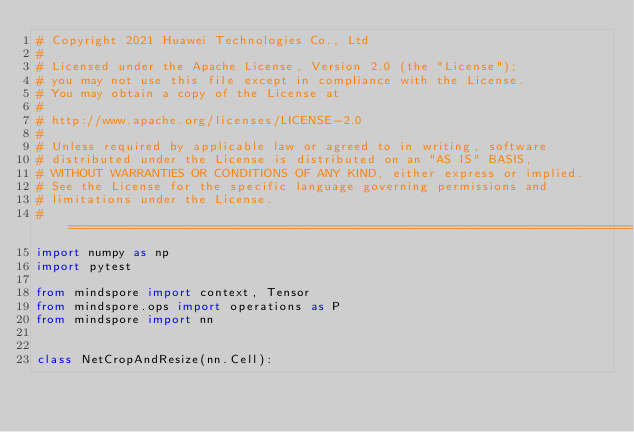<code> <loc_0><loc_0><loc_500><loc_500><_Python_># Copyright 2021 Huawei Technologies Co., Ltd
#
# Licensed under the Apache License, Version 2.0 (the "License");
# you may not use this file except in compliance with the License.
# You may obtain a copy of the License at
#
# http://www.apache.org/licenses/LICENSE-2.0
#
# Unless required by applicable law or agreed to in writing, software
# distributed under the License is distributed on an "AS IS" BASIS,
# WITHOUT WARRANTIES OR CONDITIONS OF ANY KIND, either express or implied.
# See the License for the specific language governing permissions and
# limitations under the License.
# ============================================================================
import numpy as np
import pytest

from mindspore import context, Tensor
from mindspore.ops import operations as P
from mindspore import nn


class NetCropAndResize(nn.Cell):</code> 